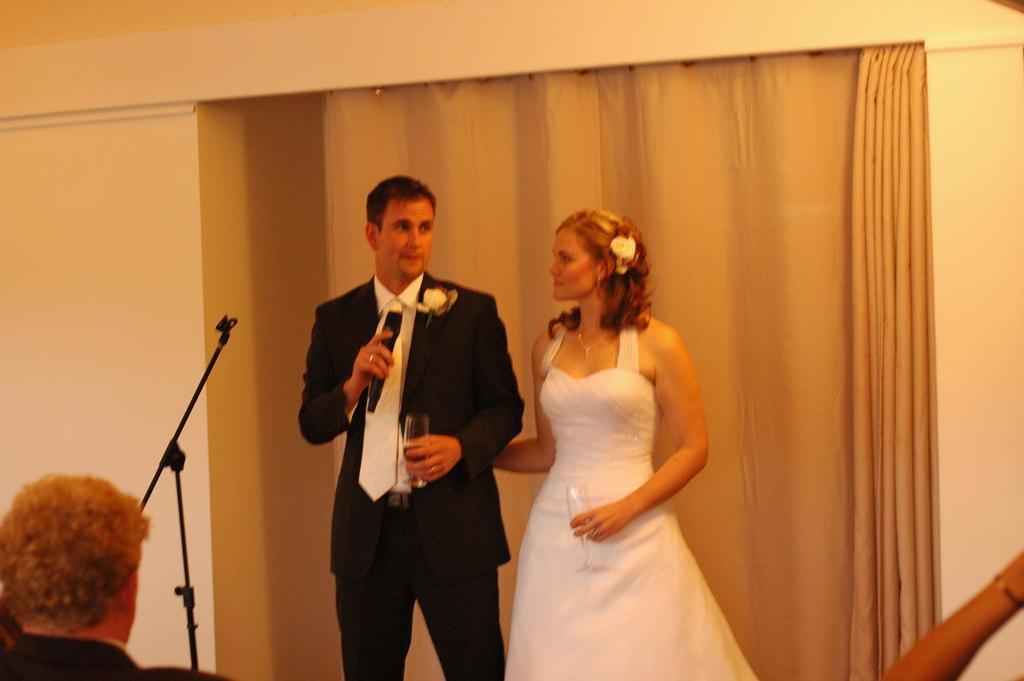Can you describe this image briefly? There is a man holding a wine glass and a mike. There is woman holding wine glass and wearing a white dress. There is a man sitting here. This is a mike stand. At background I can see a curtain. 